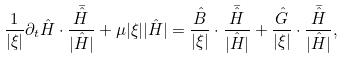Convert formula to latex. <formula><loc_0><loc_0><loc_500><loc_500>\frac { 1 } { | \xi | } \partial _ { t } \hat { H } \cdot \frac { \bar { \hat { H } } } { | \hat { H } | } + \mu | \xi | | \hat { H } | = \frac { \hat { B } } { | \xi | } \cdot \frac { \bar { \hat { H } } } { | \hat { H } | } + \frac { \hat { G } } { | \xi | } \cdot \frac { \bar { \hat { H } } } { | \hat { H } | } ,</formula> 